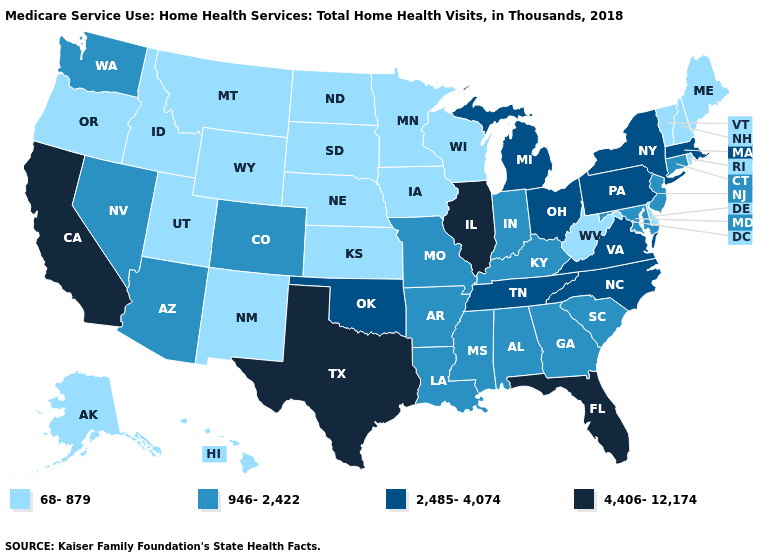Does the first symbol in the legend represent the smallest category?
Write a very short answer. Yes. Among the states that border Idaho , does Montana have the lowest value?
Give a very brief answer. Yes. Which states hav the highest value in the West?
Quick response, please. California. Name the states that have a value in the range 68-879?
Concise answer only. Alaska, Delaware, Hawaii, Idaho, Iowa, Kansas, Maine, Minnesota, Montana, Nebraska, New Hampshire, New Mexico, North Dakota, Oregon, Rhode Island, South Dakota, Utah, Vermont, West Virginia, Wisconsin, Wyoming. Which states have the highest value in the USA?
Answer briefly. California, Florida, Illinois, Texas. What is the lowest value in states that border Vermont?
Short answer required. 68-879. Name the states that have a value in the range 2,485-4,074?
Write a very short answer. Massachusetts, Michigan, New York, North Carolina, Ohio, Oklahoma, Pennsylvania, Tennessee, Virginia. Name the states that have a value in the range 4,406-12,174?
Be succinct. California, Florida, Illinois, Texas. Name the states that have a value in the range 68-879?
Write a very short answer. Alaska, Delaware, Hawaii, Idaho, Iowa, Kansas, Maine, Minnesota, Montana, Nebraska, New Hampshire, New Mexico, North Dakota, Oregon, Rhode Island, South Dakota, Utah, Vermont, West Virginia, Wisconsin, Wyoming. What is the lowest value in states that border Arizona?
Keep it brief. 68-879. Among the states that border North Carolina , does Georgia have the highest value?
Concise answer only. No. Which states have the lowest value in the South?
Answer briefly. Delaware, West Virginia. Which states have the highest value in the USA?
Answer briefly. California, Florida, Illinois, Texas. Name the states that have a value in the range 2,485-4,074?
Concise answer only. Massachusetts, Michigan, New York, North Carolina, Ohio, Oklahoma, Pennsylvania, Tennessee, Virginia. Does California have the highest value in the West?
Quick response, please. Yes. 